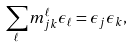Convert formula to latex. <formula><loc_0><loc_0><loc_500><loc_500>\sum _ { \ell } m _ { j k } ^ { \ell } \epsilon _ { \ell } = \epsilon _ { j } \epsilon _ { k } ,</formula> 